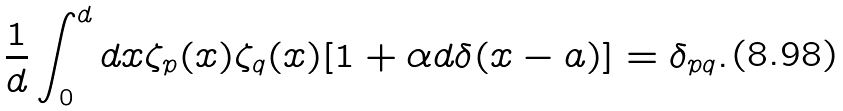Convert formula to latex. <formula><loc_0><loc_0><loc_500><loc_500>\frac { 1 } { d } \int _ { 0 } ^ { d } d x \zeta _ { p } ( x ) \zeta _ { q } ( x ) [ 1 + \alpha d \delta ( x - a ) ] = \delta _ { p q } .</formula> 